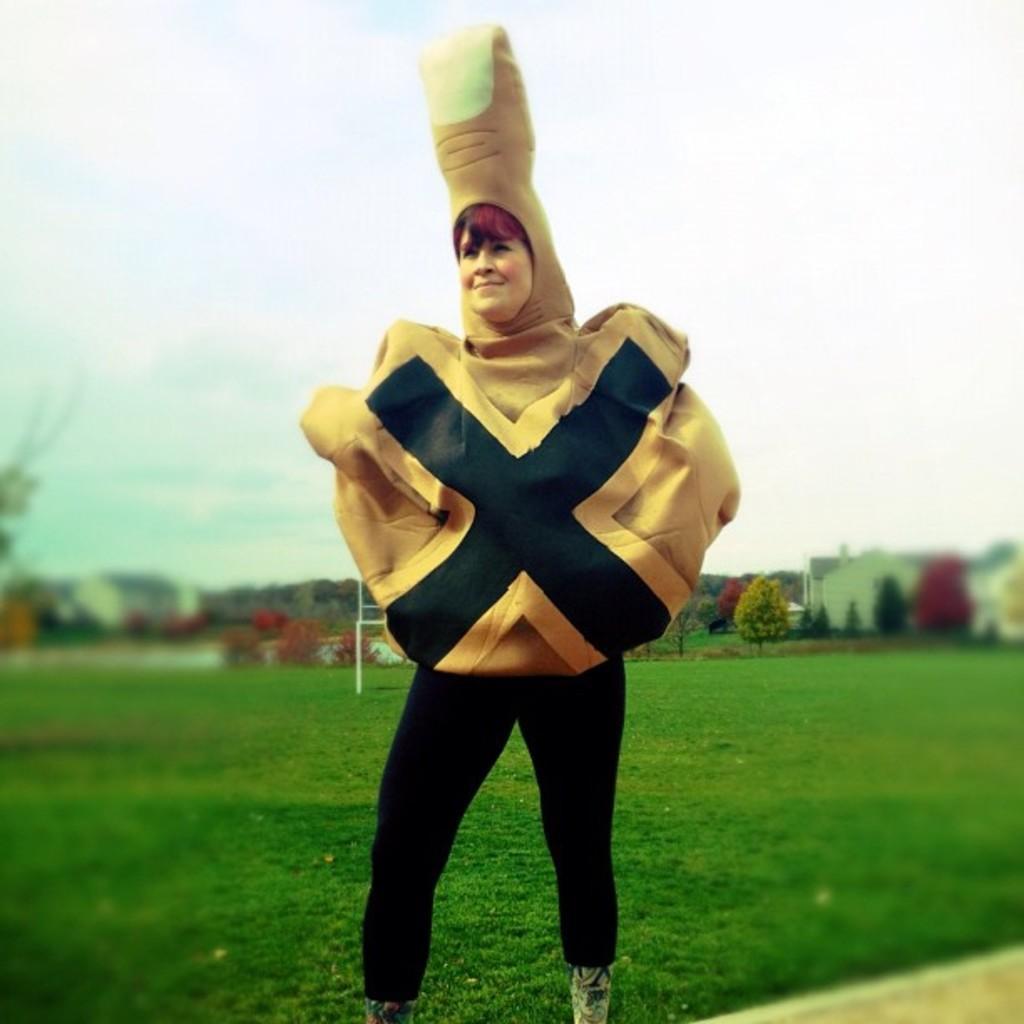In one or two sentences, can you explain what this image depicts? In this image there is a person standing on the grass wearing drama costume, behind her there are some trees and other things. 